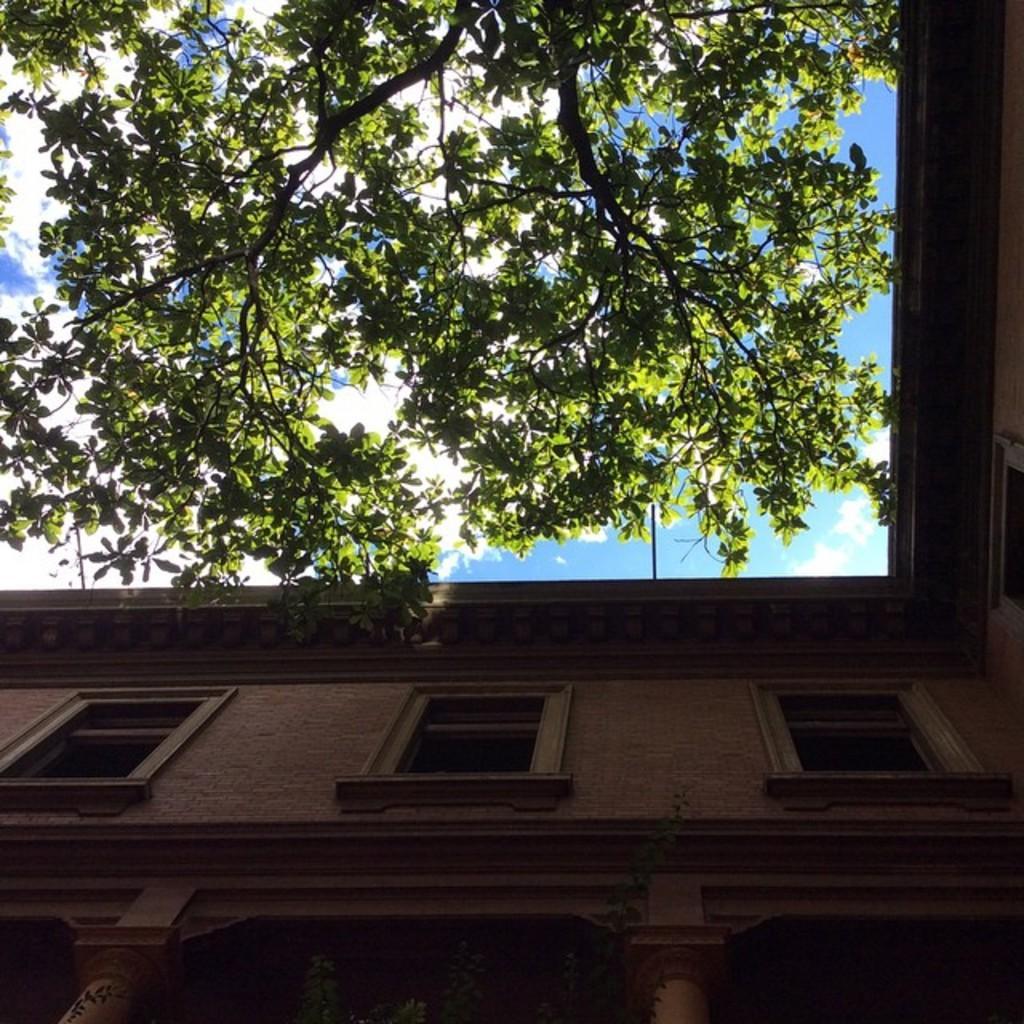Could you give a brief overview of what you see in this image? In this image I see a building and I see the trees and in the background I see the clear sky. 